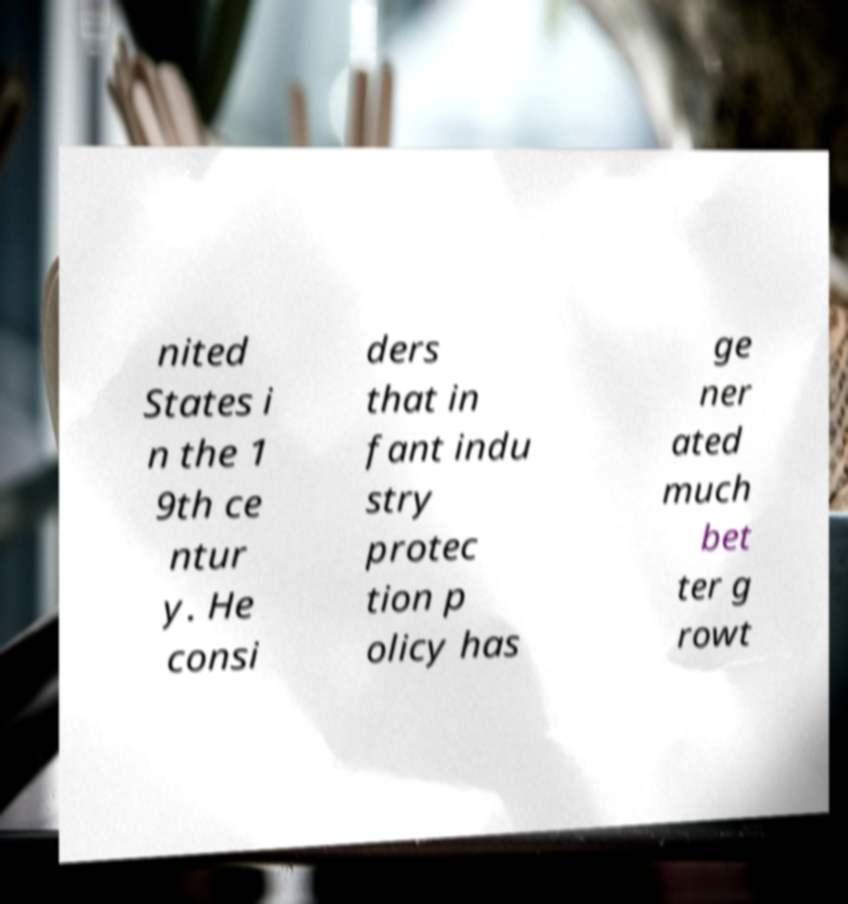What messages or text are displayed in this image? I need them in a readable, typed format. nited States i n the 1 9th ce ntur y. He consi ders that in fant indu stry protec tion p olicy has ge ner ated much bet ter g rowt 